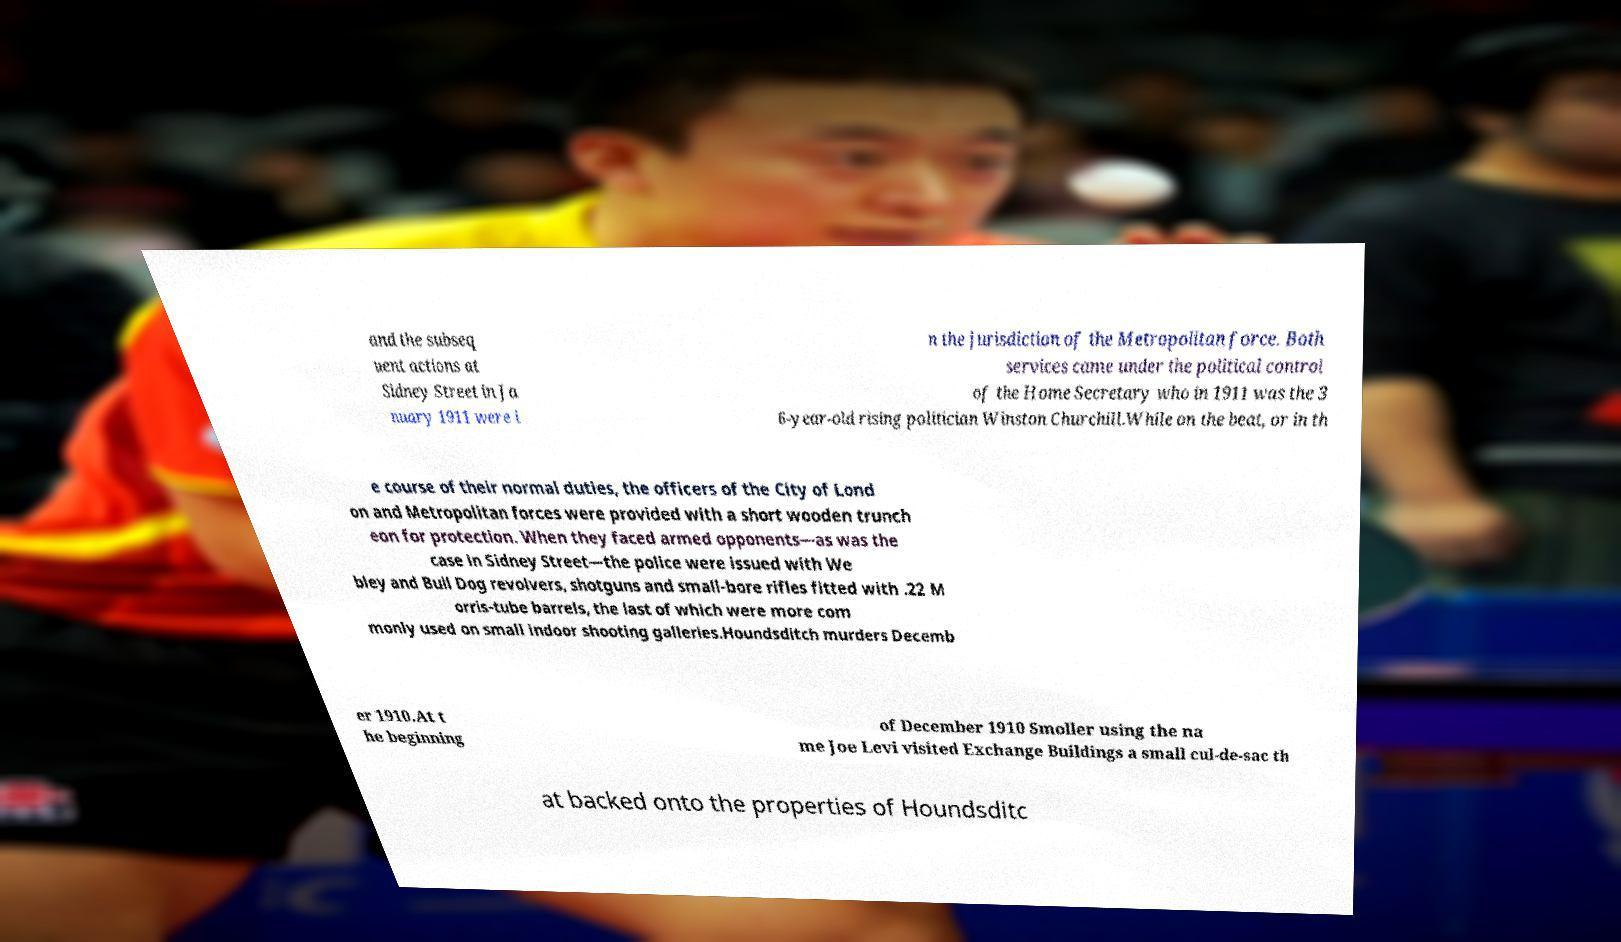Could you extract and type out the text from this image? and the subseq uent actions at Sidney Street in Ja nuary 1911 were i n the jurisdiction of the Metropolitan force. Both services came under the political control of the Home Secretary who in 1911 was the 3 6-year-old rising politician Winston Churchill.While on the beat, or in th e course of their normal duties, the officers of the City of Lond on and Metropolitan forces were provided with a short wooden trunch eon for protection. When they faced armed opponents—as was the case in Sidney Street—the police were issued with We bley and Bull Dog revolvers, shotguns and small-bore rifles fitted with .22 M orris-tube barrels, the last of which were more com monly used on small indoor shooting galleries.Houndsditch murders Decemb er 1910.At t he beginning of December 1910 Smoller using the na me Joe Levi visited Exchange Buildings a small cul-de-sac th at backed onto the properties of Houndsditc 